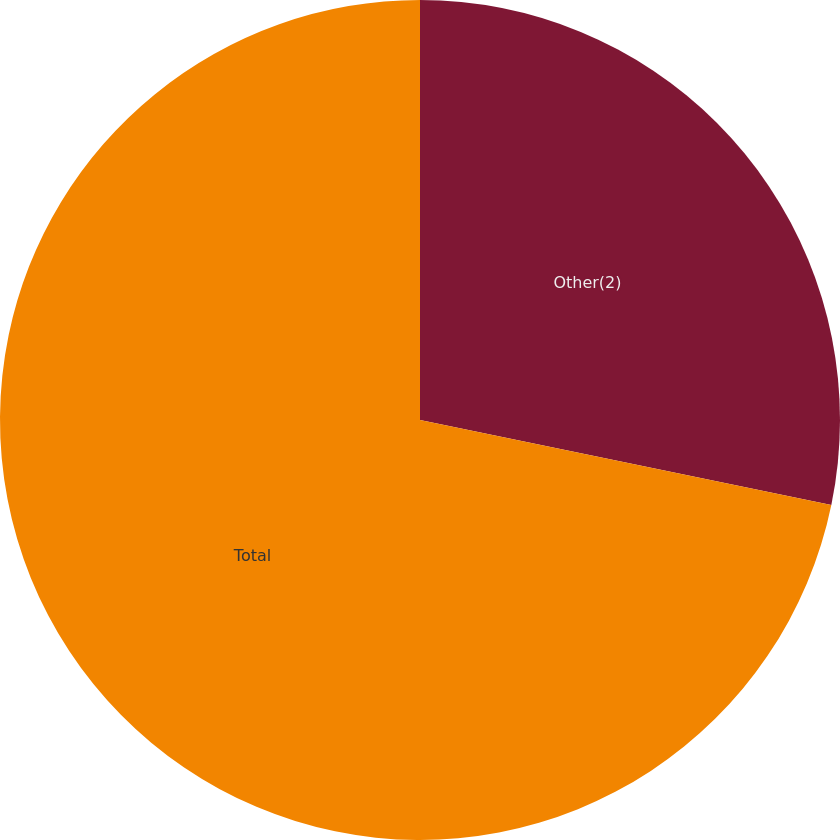Convert chart to OTSL. <chart><loc_0><loc_0><loc_500><loc_500><pie_chart><fcel>Other(2)<fcel>Total<nl><fcel>28.24%<fcel>71.76%<nl></chart> 